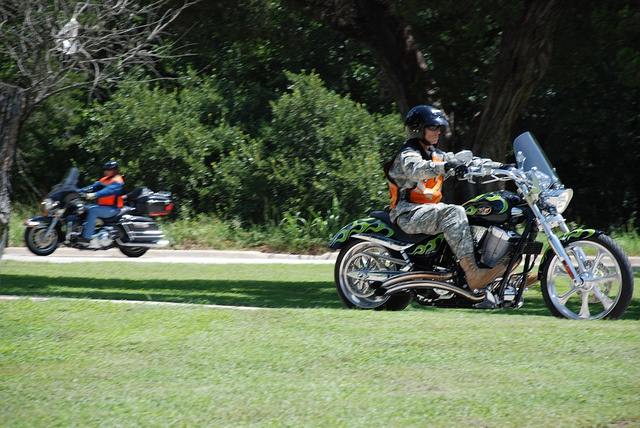Describe the objects in this image and their specific colors. I can see motorcycle in gray, black, darkgray, and lightgray tones, people in gray, black, darkgray, and lightgray tones, motorcycle in gray, black, darkgray, and lightgray tones, and people in gray, black, blue, and navy tones in this image. 